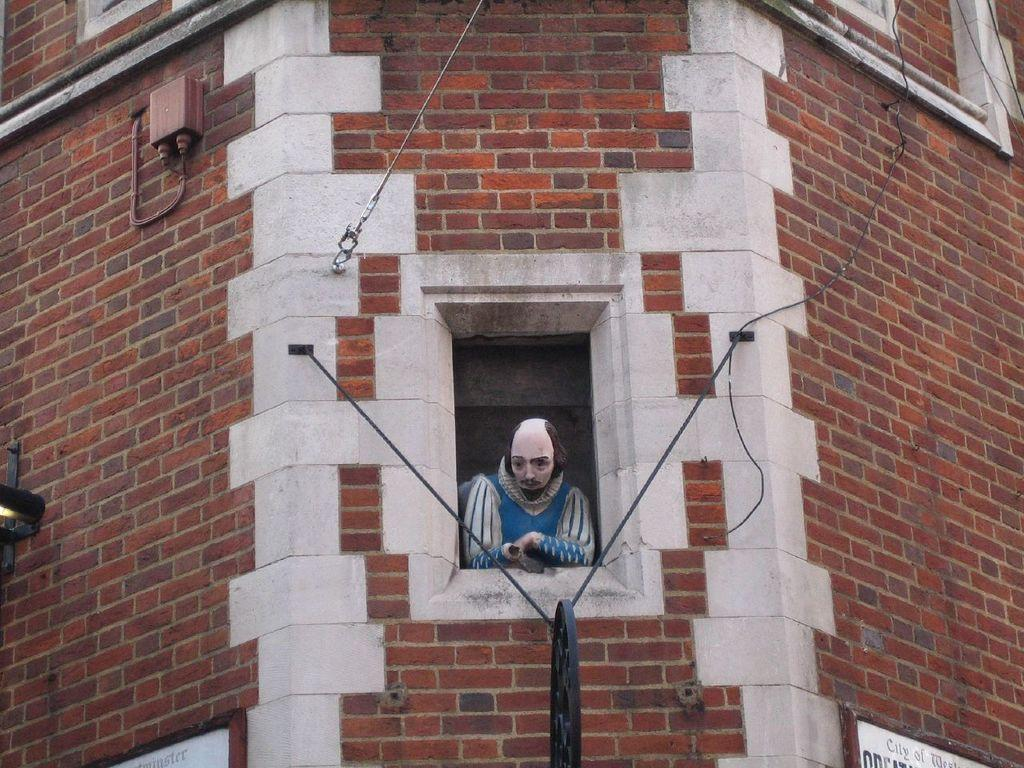What type of structure is present in the image? There is a building in the image. What can be seen from one of the windows in the building? There is a human statue visible from a statue visible from a window in the image. What mechanical component is present in the image? There is a wheel in the image. What type of information is displayed on the wall in the image? There are boards with text on the wall in the image. How many friends are sitting on the lumber in the image? There is no lumber or friends present in the image. What type of attraction is the human statue in the image? The provided facts do not mention any attraction associated with the human statue; it is simply a statue visible from a window. 